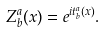<formula> <loc_0><loc_0><loc_500><loc_500>Z _ { b } ^ { a } ( x ) = e ^ { i t ^ { a } _ { b } ( x ) } .</formula> 